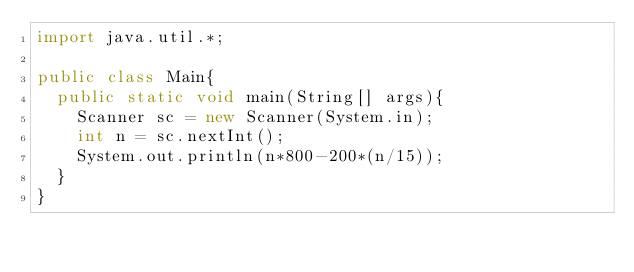Convert code to text. <code><loc_0><loc_0><loc_500><loc_500><_Java_>import java.util.*;

public class Main{
  public static void main(String[] args){
    Scanner sc = new Scanner(System.in);
    int n = sc.nextInt();
    System.out.println(n*800-200*(n/15));
  }
}
</code> 